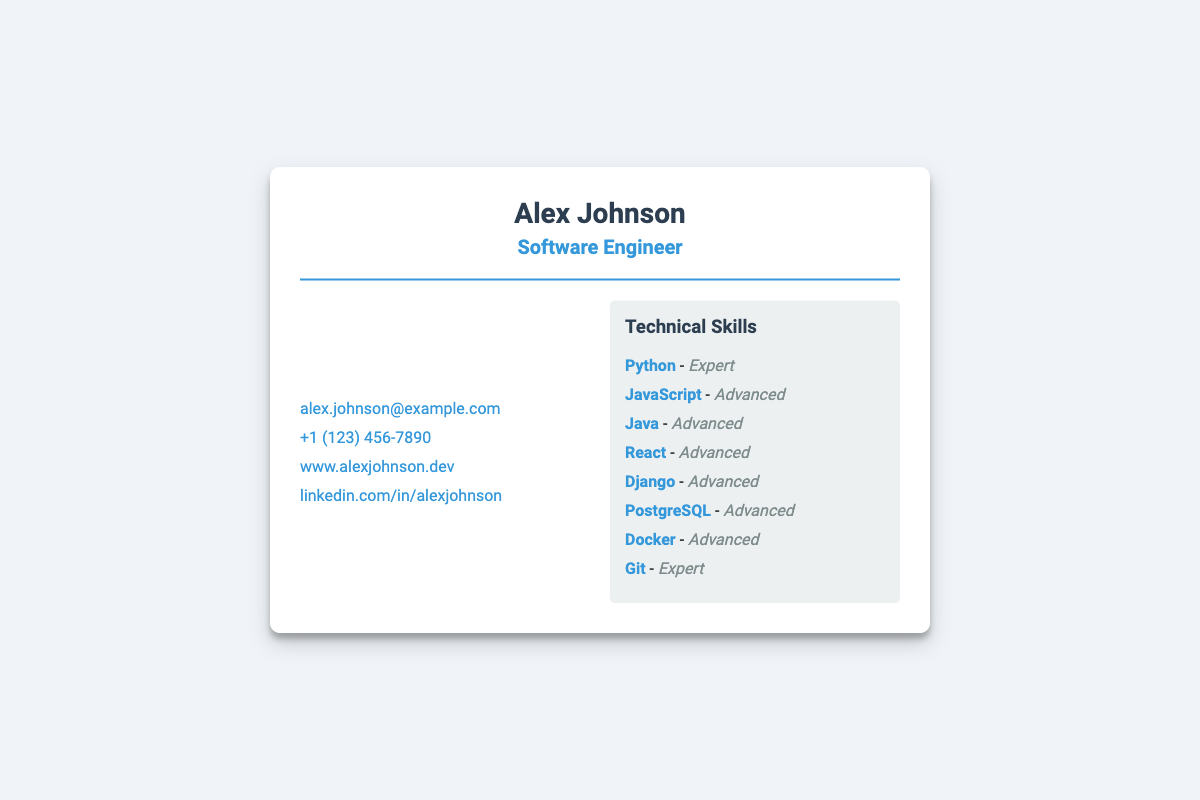What is the name on the business card? The name displayed prominently on the business card is Alex Johnson.
Answer: Alex Johnson What is the profession listed on the business card? The profession mentioned under the name is Software Engineer.
Answer: Software Engineer How many technical skills are listed on the business card? The card lists eight different technical skills under the 'Technical Skills' section.
Answer: Eight What is the proficiency level of Python? The proficiency level for Python is stated as Expert.
Answer: Expert Which programming language is rated the same as JavaScript in proficiency? Java and JavaScript are both rated as Advanced in proficiency.
Answer: Java What is the email address provided on the business card? The email provided in the contact information is alex.johnson@example.com.
Answer: alex.johnson@example.com What technology does the card identify as having the highest proficiency level? The card identifies Python and Git as having the highest proficiency level of Expert.
Answer: Expert What social media platform profile link is included on the card? The linked social media profile provided on the card is for LinkedIn under the username alexjohnson.
Answer: linkedin.com/in/alexjohnson 